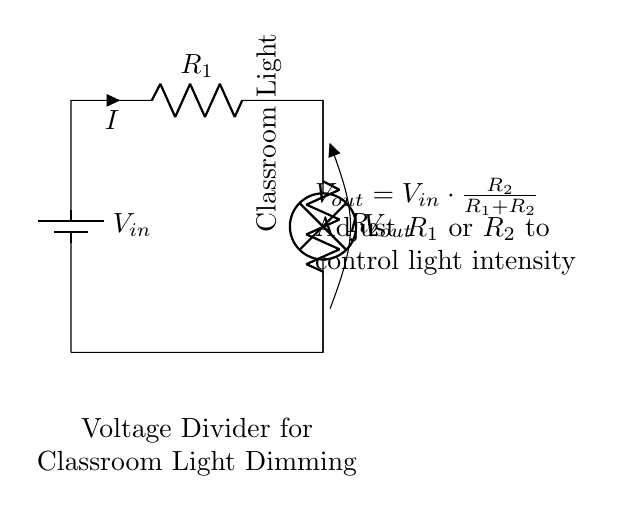What type of circuit is depicted? The circuit shown is a voltage divider, which is used to reduce voltage. It consists of two resistors and is used here specifically to dim lights.
Answer: Voltage divider What is the role of R1 in this circuit? R1 works with R2 to divide the input voltage, affecting the overall output voltage. The resistance value of R1 influences how much voltage appears across R2 and hence how bright the light will be.
Answer: Voltage divider What does Vout represent in this diagram? Vout represents the voltage across R2, which is also the voltage powering the classroom light. It is determined by the formula provided, depending on the resistances.
Answer: The voltage across R2 How can you increase the brightness of the classroom light? To increase brightness, you can decrease the resistance of R2 or increase the resistance of R1, as this will adjust the output voltage upwards.
Answer: Decrease R2 or increase R1 What happens to Vout if R2 is much larger than R1? If R2 is much larger than R1, the output voltage Vout approaches Vin, which means the light will be brighter, as more voltage will be available to it.
Answer: Approaches Vin What is the formula for Vout in this circuit? The formula is Vout equals Vin multiplied by R2 divided by (R1 plus R2), showing how the resistances dictate the output voltage.
Answer: Vout = Vin * (R2 / (R1 + R2)) 